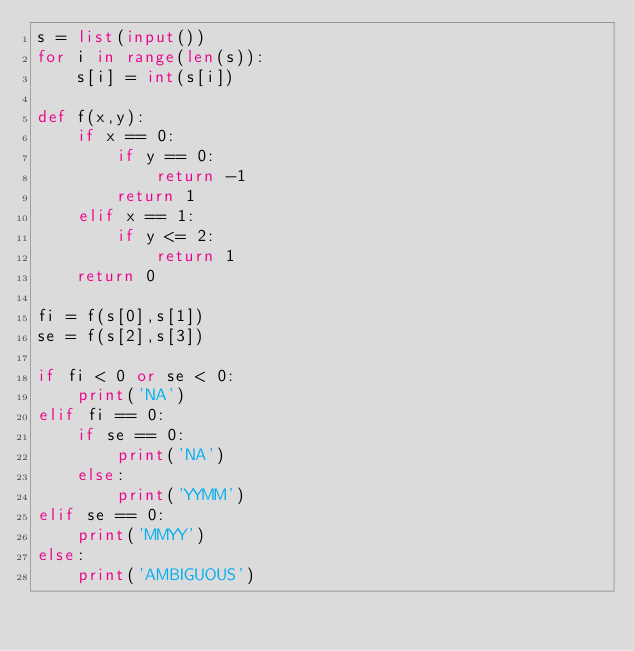<code> <loc_0><loc_0><loc_500><loc_500><_Python_>s = list(input())
for i in range(len(s)):
    s[i] = int(s[i])

def f(x,y):
    if x == 0:
        if y == 0:
            return -1
        return 1
    elif x == 1:
        if y <= 2:
            return 1
    return 0

fi = f(s[0],s[1])
se = f(s[2],s[3])

if fi < 0 or se < 0:
    print('NA')
elif fi == 0:
    if se == 0:
        print('NA')
    else:
        print('YYMM')
elif se == 0:
    print('MMYY')
else:
    print('AMBIGUOUS')
</code> 